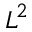Convert formula to latex. <formula><loc_0><loc_0><loc_500><loc_500>L ^ { 2 }</formula> 